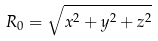Convert formula to latex. <formula><loc_0><loc_0><loc_500><loc_500>R _ { 0 } = \sqrt { x ^ { 2 } + y ^ { 2 } + z ^ { 2 } }</formula> 